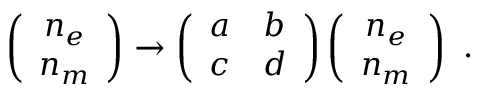Convert formula to latex. <formula><loc_0><loc_0><loc_500><loc_500>\left ( \begin{array} { c } { { n _ { e } } } \\ { { n _ { m } } } \end{array} \right ) \to \left ( \begin{array} { c c } { a } & { b } \\ { c } & { d } \end{array} \right ) \left ( \begin{array} { c } { { n _ { e } } } \\ { { n _ { m } } } \end{array} \right ) \ .</formula> 